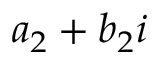<formula> <loc_0><loc_0><loc_500><loc_500>a _ { 2 } + b _ { 2 } i</formula> 